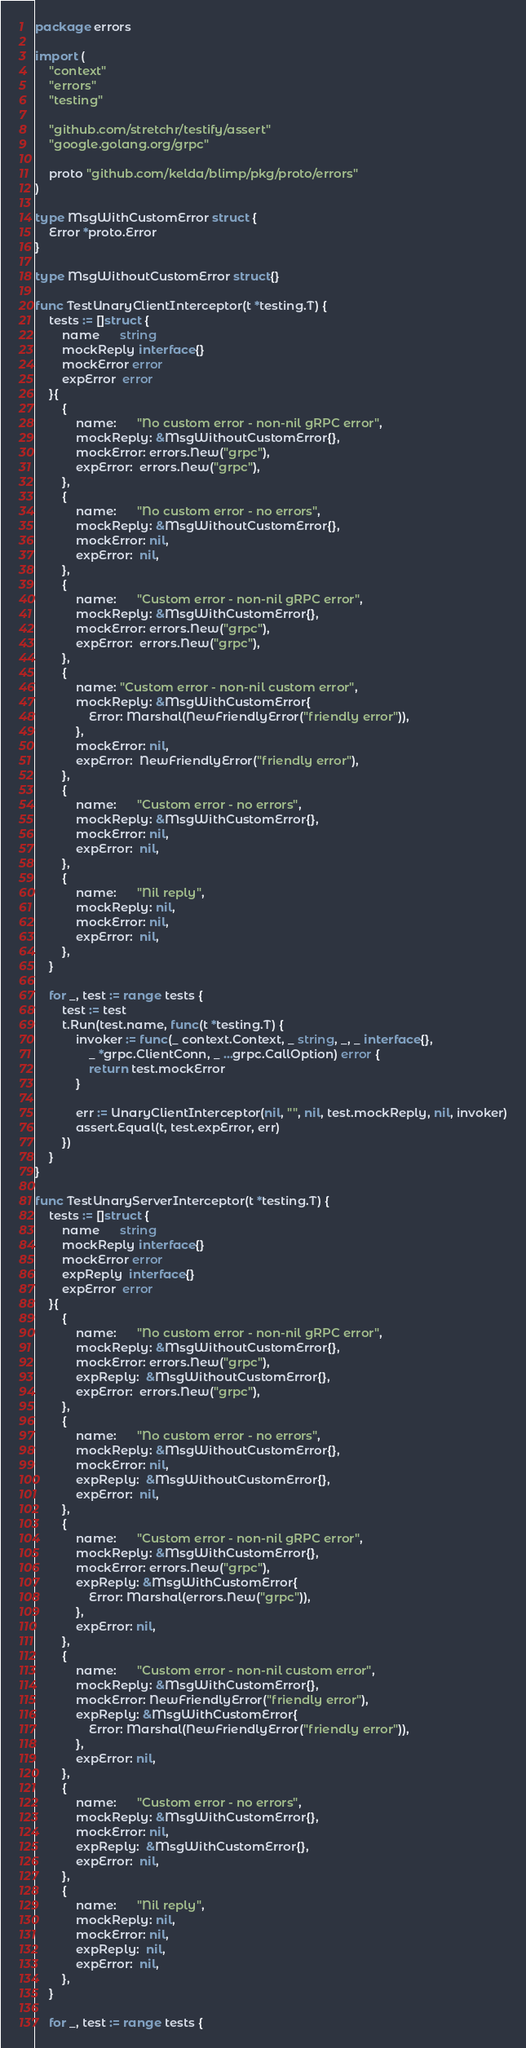<code> <loc_0><loc_0><loc_500><loc_500><_Go_>package errors

import (
	"context"
	"errors"
	"testing"

	"github.com/stretchr/testify/assert"
	"google.golang.org/grpc"

	proto "github.com/kelda/blimp/pkg/proto/errors"
)

type MsgWithCustomError struct {
	Error *proto.Error
}

type MsgWithoutCustomError struct{}

func TestUnaryClientInterceptor(t *testing.T) {
	tests := []struct {
		name      string
		mockReply interface{}
		mockError error
		expError  error
	}{
		{
			name:      "No custom error - non-nil gRPC error",
			mockReply: &MsgWithoutCustomError{},
			mockError: errors.New("grpc"),
			expError:  errors.New("grpc"),
		},
		{
			name:      "No custom error - no errors",
			mockReply: &MsgWithoutCustomError{},
			mockError: nil,
			expError:  nil,
		},
		{
			name:      "Custom error - non-nil gRPC error",
			mockReply: &MsgWithCustomError{},
			mockError: errors.New("grpc"),
			expError:  errors.New("grpc"),
		},
		{
			name: "Custom error - non-nil custom error",
			mockReply: &MsgWithCustomError{
				Error: Marshal(NewFriendlyError("friendly error")),
			},
			mockError: nil,
			expError:  NewFriendlyError("friendly error"),
		},
		{
			name:      "Custom error - no errors",
			mockReply: &MsgWithCustomError{},
			mockError: nil,
			expError:  nil,
		},
		{
			name:      "Nil reply",
			mockReply: nil,
			mockError: nil,
			expError:  nil,
		},
	}

	for _, test := range tests {
		test := test
		t.Run(test.name, func(t *testing.T) {
			invoker := func(_ context.Context, _ string, _, _ interface{},
				_ *grpc.ClientConn, _ ...grpc.CallOption) error {
				return test.mockError
			}

			err := UnaryClientInterceptor(nil, "", nil, test.mockReply, nil, invoker)
			assert.Equal(t, test.expError, err)
		})
	}
}

func TestUnaryServerInterceptor(t *testing.T) {
	tests := []struct {
		name      string
		mockReply interface{}
		mockError error
		expReply  interface{}
		expError  error
	}{
		{
			name:      "No custom error - non-nil gRPC error",
			mockReply: &MsgWithoutCustomError{},
			mockError: errors.New("grpc"),
			expReply:  &MsgWithoutCustomError{},
			expError:  errors.New("grpc"),
		},
		{
			name:      "No custom error - no errors",
			mockReply: &MsgWithoutCustomError{},
			mockError: nil,
			expReply:  &MsgWithoutCustomError{},
			expError:  nil,
		},
		{
			name:      "Custom error - non-nil gRPC error",
			mockReply: &MsgWithCustomError{},
			mockError: errors.New("grpc"),
			expReply: &MsgWithCustomError{
				Error: Marshal(errors.New("grpc")),
			},
			expError: nil,
		},
		{
			name:      "Custom error - non-nil custom error",
			mockReply: &MsgWithCustomError{},
			mockError: NewFriendlyError("friendly error"),
			expReply: &MsgWithCustomError{
				Error: Marshal(NewFriendlyError("friendly error")),
			},
			expError: nil,
		},
		{
			name:      "Custom error - no errors",
			mockReply: &MsgWithCustomError{},
			mockError: nil,
			expReply:  &MsgWithCustomError{},
			expError:  nil,
		},
		{
			name:      "Nil reply",
			mockReply: nil,
			mockError: nil,
			expReply:  nil,
			expError:  nil,
		},
	}

	for _, test := range tests {</code> 